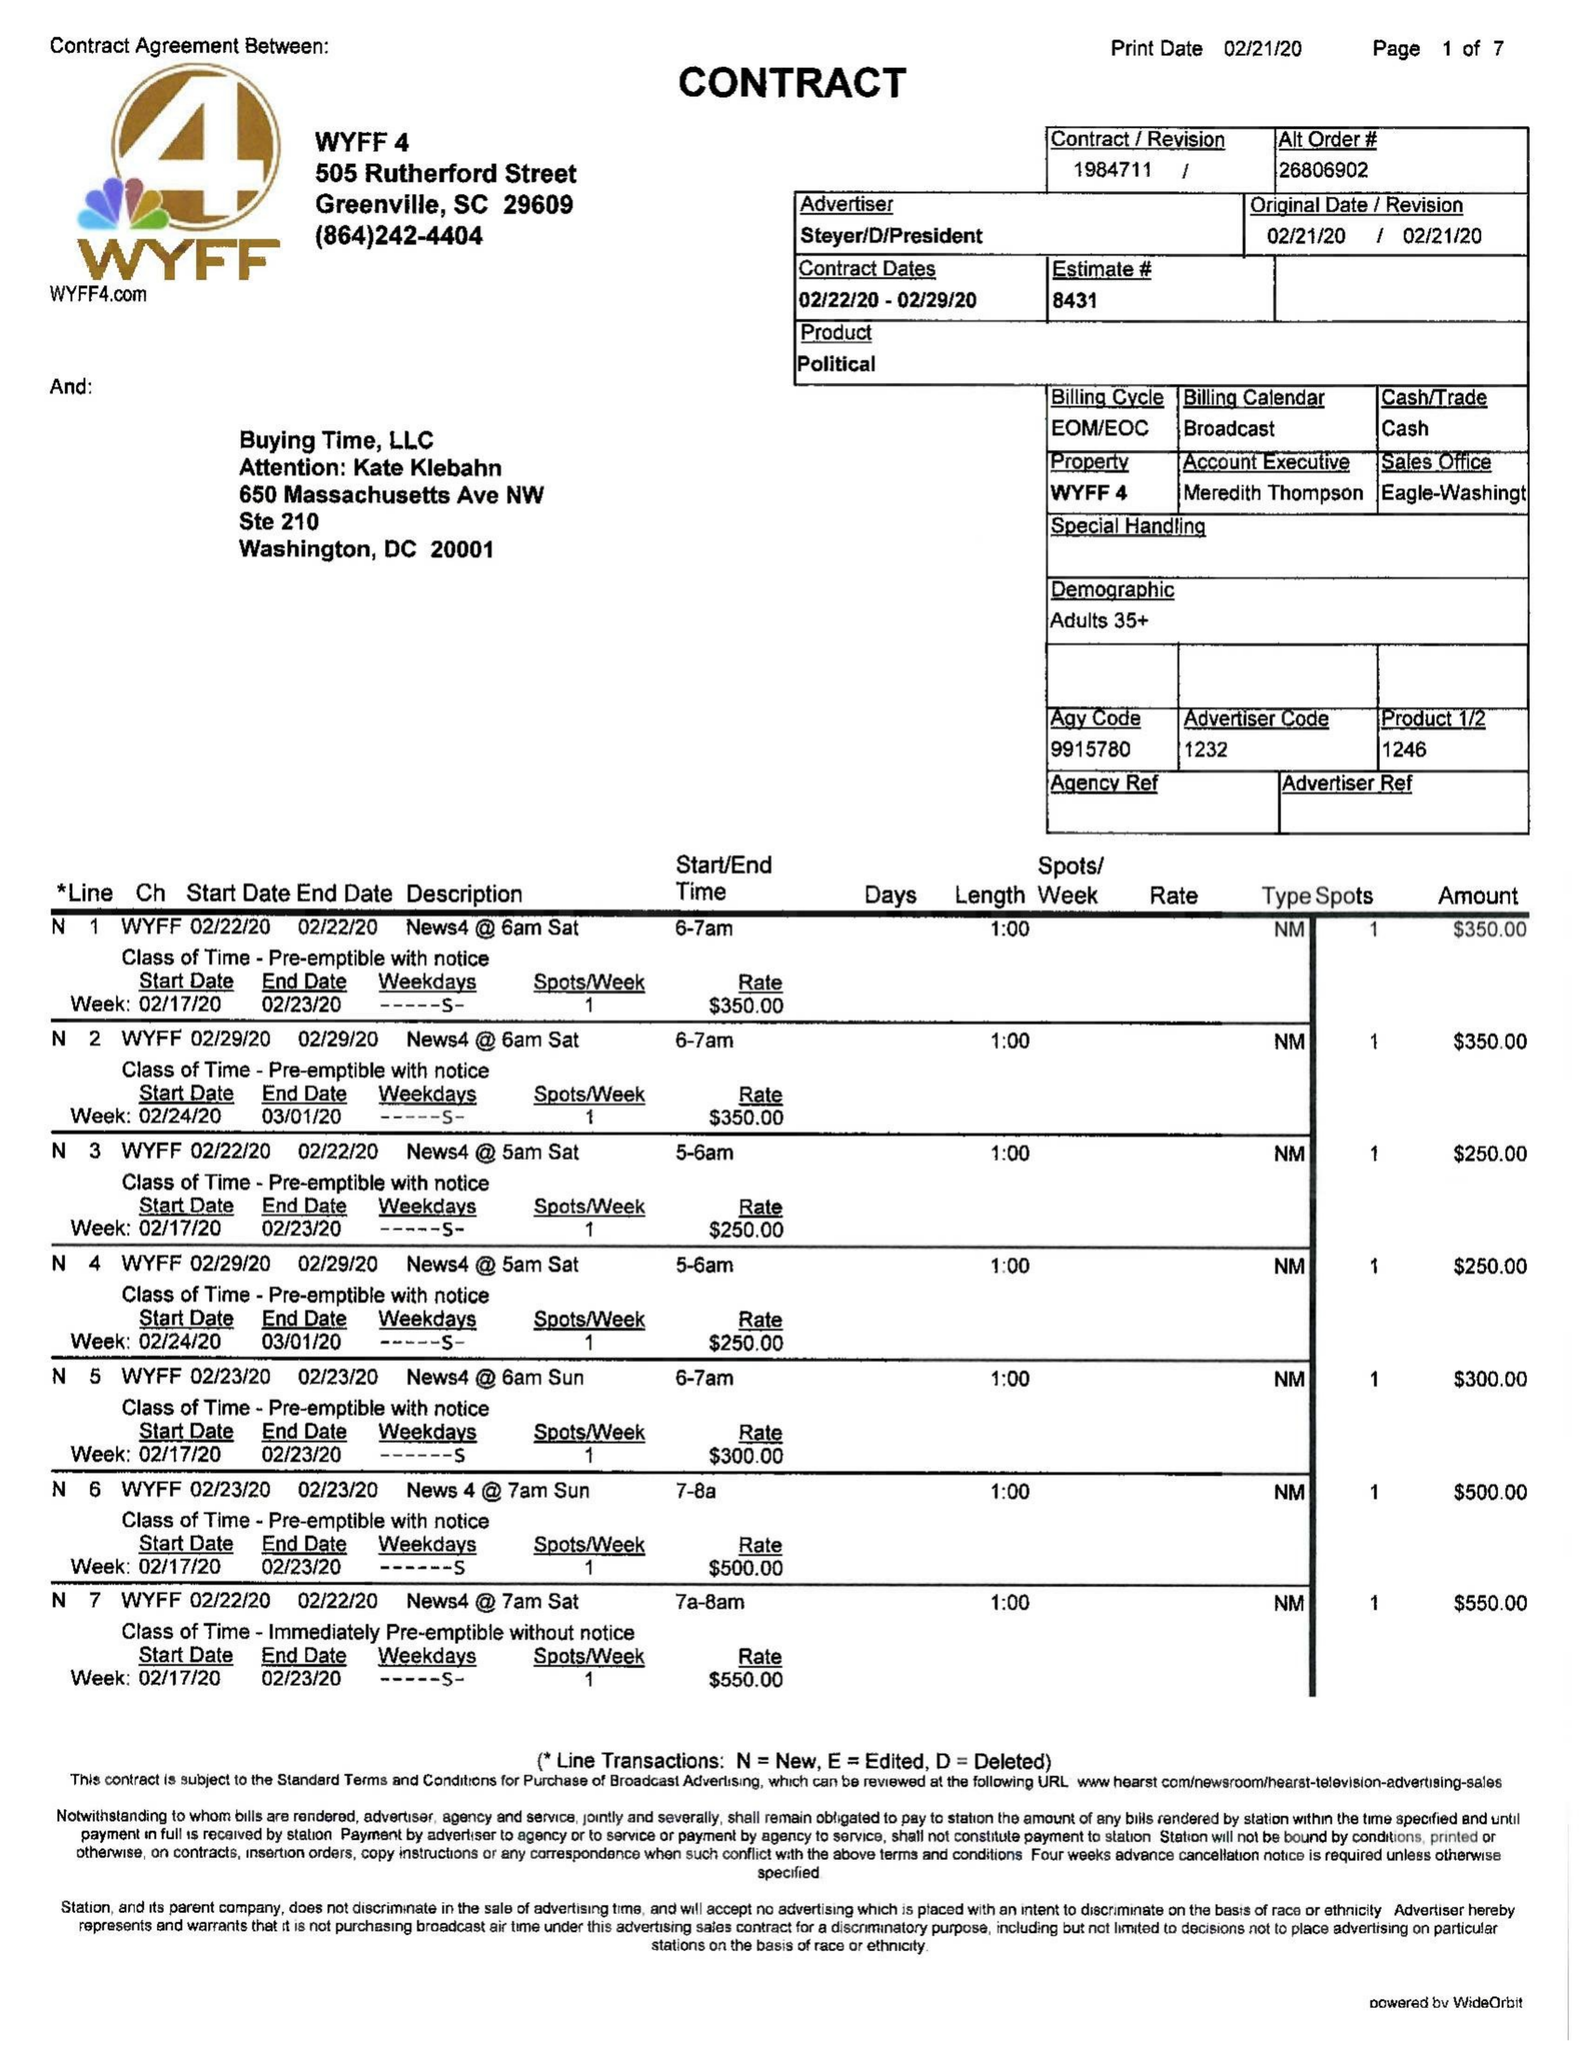What is the value for the flight_to?
Answer the question using a single word or phrase. 02/29/20 